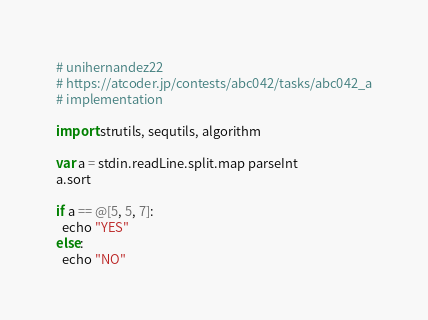<code> <loc_0><loc_0><loc_500><loc_500><_Nim_># unihernandez22
# https://atcoder.jp/contests/abc042/tasks/abc042_a
# implementation

import strutils, sequtils, algorithm

var a = stdin.readLine.split.map parseInt
a.sort

if a == @[5, 5, 7]:
  echo "YES"
else:
  echo "NO"
</code> 